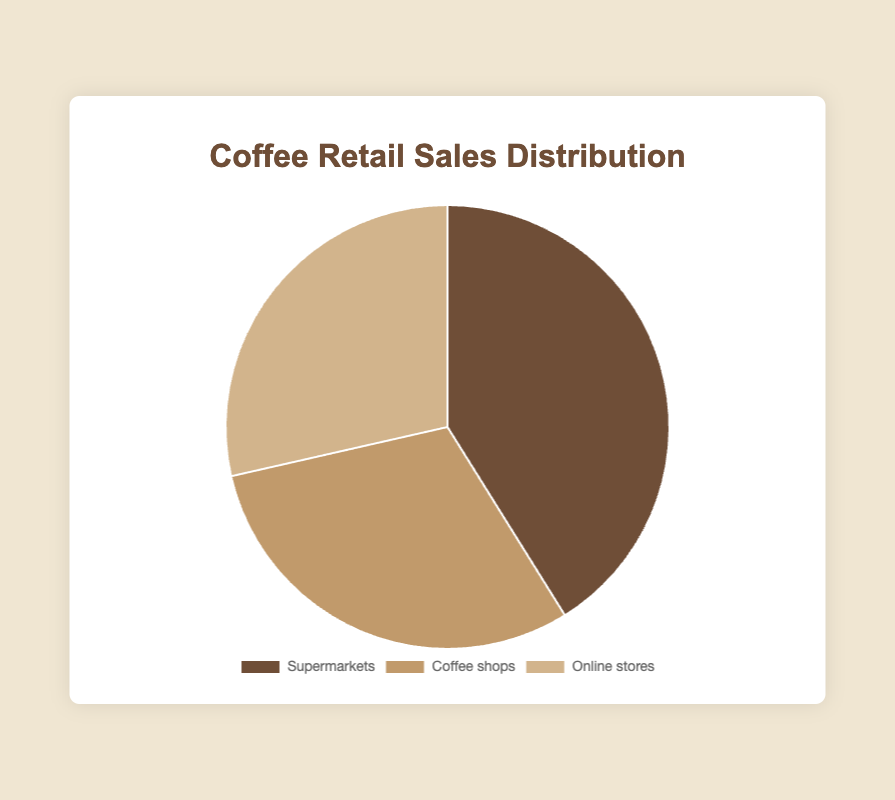Which retailer type has the highest percentage of coffee sales? Look at the pie chart and identify the segment with the largest portion. The label indicates the corresponding retailer type.
Answer: Supermarkets Which retailer type has the lowest percentage of coffee sales? Examine the pie chart and find the smallest segment. The label will tell you which retailer type it represents.
Answer: Coffee shops What is the combined percentage of sales for Online stores and Coffee shops? Add the percentages for Online stores (45.7%) and Coffee shops (48.5%). The summed value gives you the combined percentage.
Answer: 45.5% Which retailer type is represented by the lightest color in the chart? Observe the pie chart and identify the segment with the lightest shade. The label of this segment will give the corresponding retailer type.
Answer: Online stores How much greater is the percentage of sales for Supermarkets compared to Online stores? Subtract the percentage for Online stores (45.7%) from the percentage for Supermarkets (70.5%). The difference is the answer.
Answer: 24.8% What percentage of sales does the largest retailer (Walmart) contribute to the Supermarkets' total? Walmart contributes 35.2%. To find the proportion of the Supermarkets' total (70.5%) it makes up, use the formula: (35.2 / 70.5) * 100%.
Answer: 49.9% If Coffee shops and Online stores combined have a greater percentage of sales than Supermarkets, by how much? Add the percentages for Coffee shops (48.5%) and Online stores (45.7%) and subtract the Supermarkets' percentage (70.5%). The result is your answer.
Answer: 23.7% 